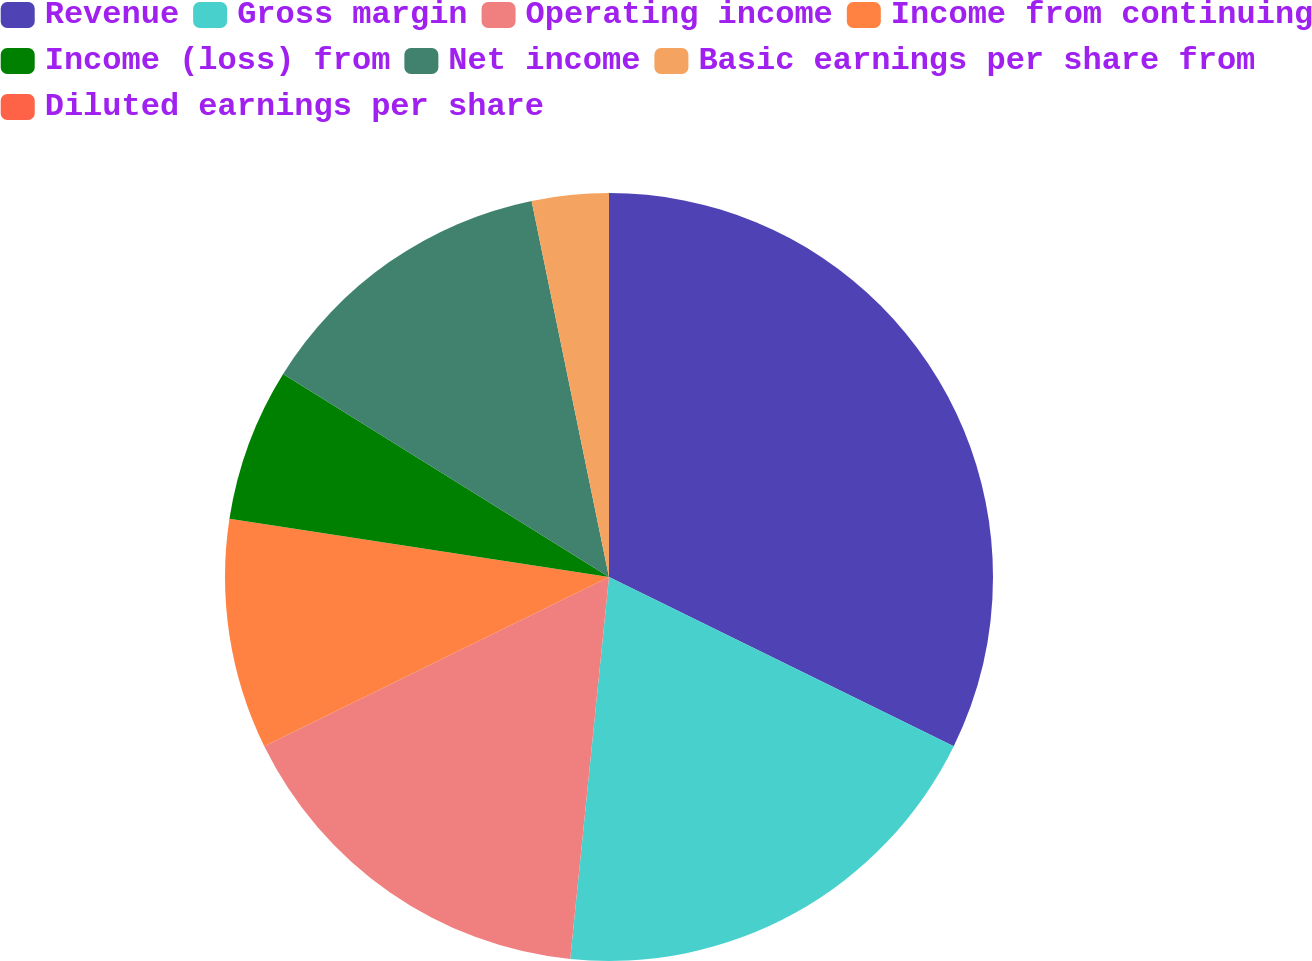<chart> <loc_0><loc_0><loc_500><loc_500><pie_chart><fcel>Revenue<fcel>Gross margin<fcel>Operating income<fcel>Income from continuing<fcel>Income (loss) from<fcel>Net income<fcel>Basic earnings per share from<fcel>Diluted earnings per share<nl><fcel>32.26%<fcel>19.35%<fcel>16.13%<fcel>9.68%<fcel>6.45%<fcel>12.9%<fcel>3.23%<fcel>0.0%<nl></chart> 